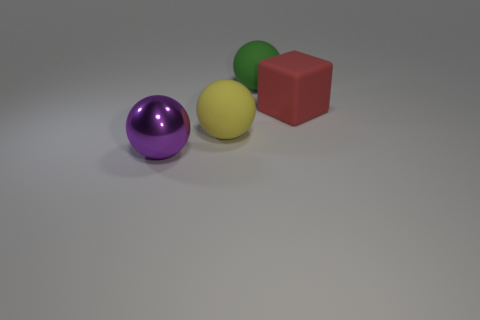Subtract all big matte balls. How many balls are left? 1 Add 4 red matte things. How many objects exist? 8 Subtract all spheres. How many objects are left? 1 Subtract 1 cubes. How many cubes are left? 0 Subtract all brown spheres. Subtract all purple cylinders. How many spheres are left? 3 Add 1 small spheres. How many small spheres exist? 1 Subtract 1 yellow spheres. How many objects are left? 3 Subtract all cyan cubes. Subtract all metallic balls. How many objects are left? 3 Add 4 purple objects. How many purple objects are left? 5 